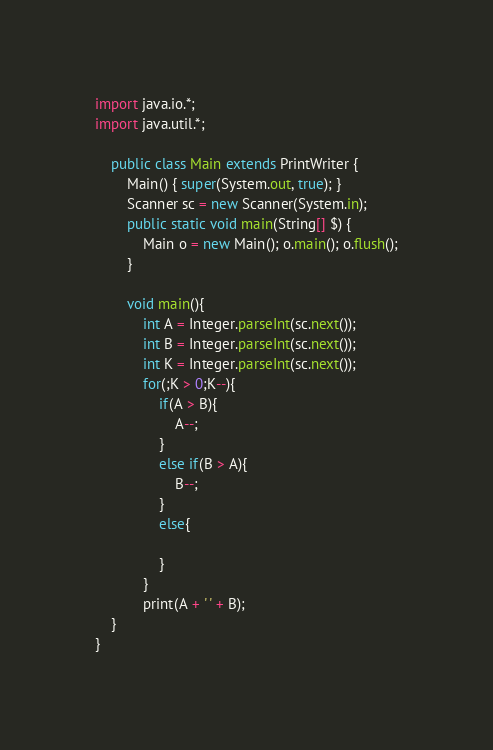<code> <loc_0><loc_0><loc_500><loc_500><_Java_>import java.io.*;
import java.util.*;

    public class Main extends PrintWriter {
        Main() { super(System.out, true); }
        Scanner sc = new Scanner(System.in);
        public static void main(String[] $) {
            Main o = new Main(); o.main(); o.flush();
        }

        void main(){
            int A = Integer.parseInt(sc.next());
            int B = Integer.parseInt(sc.next());
            int K = Integer.parseInt(sc.next());
            for(;K > 0;K--){
                if(A > B){
                    A--;
                }
                else if(B > A){
                    B--;
                }
                else{

                }
            }
            print(A + ' ' + B);
    }
}
</code> 